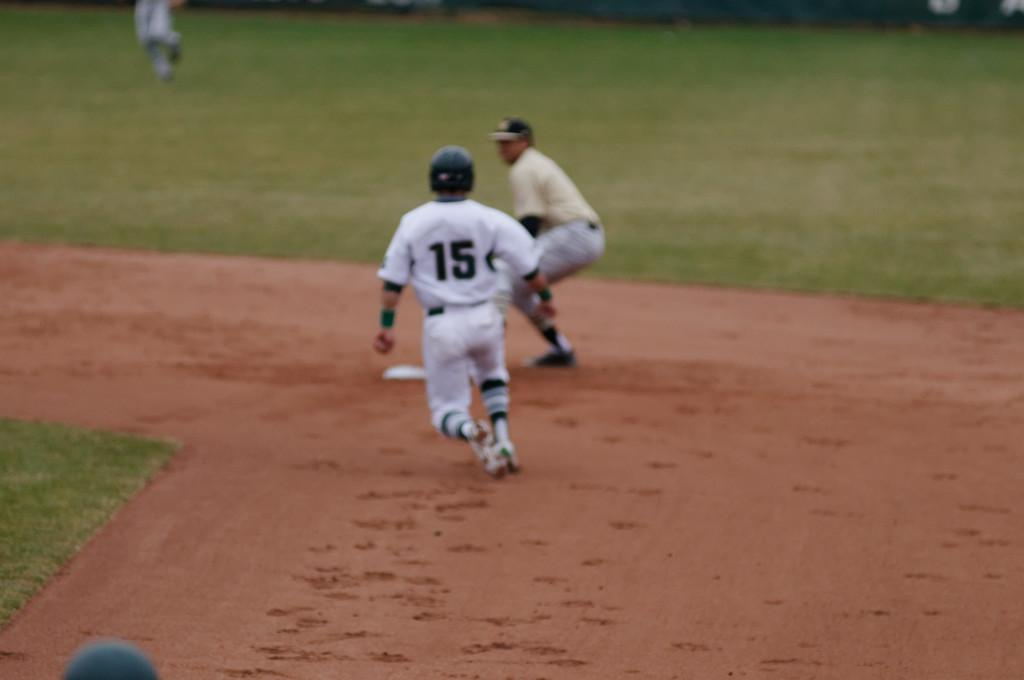<image>
Render a clear and concise summary of the photo. Baseball player with the number 15 running to the second base on the field. 